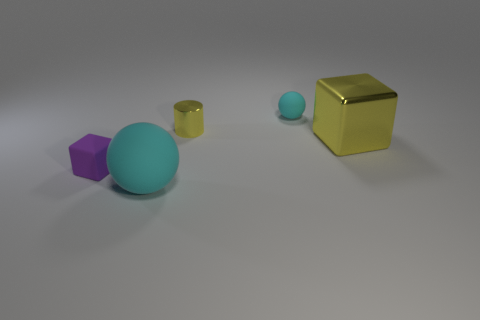Subtract all cyan spheres. How many were subtracted if there are1cyan spheres left? 1 Subtract all yellow cubes. How many cubes are left? 1 Add 2 small gray rubber spheres. How many objects exist? 7 Subtract all spheres. How many objects are left? 3 Add 5 tiny yellow metal things. How many tiny yellow metal things exist? 6 Subtract 1 yellow cylinders. How many objects are left? 4 Subtract 1 spheres. How many spheres are left? 1 Subtract all gray spheres. Subtract all gray blocks. How many spheres are left? 2 Subtract all brown cylinders. How many purple blocks are left? 1 Subtract all small blue cylinders. Subtract all cyan spheres. How many objects are left? 3 